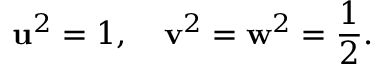<formula> <loc_0><loc_0><loc_500><loc_500>u ^ { 2 } = 1 , \quad v ^ { 2 } = w ^ { 2 } = \frac { 1 } { 2 } .</formula> 